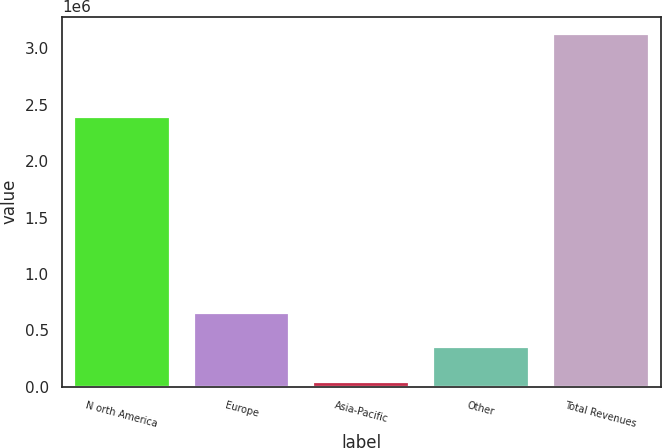<chart> <loc_0><loc_0><loc_500><loc_500><bar_chart><fcel>N orth America<fcel>Europe<fcel>Asia-Pacific<fcel>Other<fcel>Total Revenues<nl><fcel>2.38846e+06<fcel>658185<fcel>41261<fcel>349723<fcel>3.12588e+06<nl></chart> 